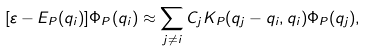Convert formula to latex. <formula><loc_0><loc_0><loc_500><loc_500>[ \varepsilon - E _ { P } ( q _ { i } ) ] \Phi _ { P } ( q _ { i } ) \approx \sum _ { j \not = i } C _ { j } K _ { P } ( q _ { j } - q _ { i } , q _ { i } ) \Phi _ { P } ( q _ { j } ) ,</formula> 